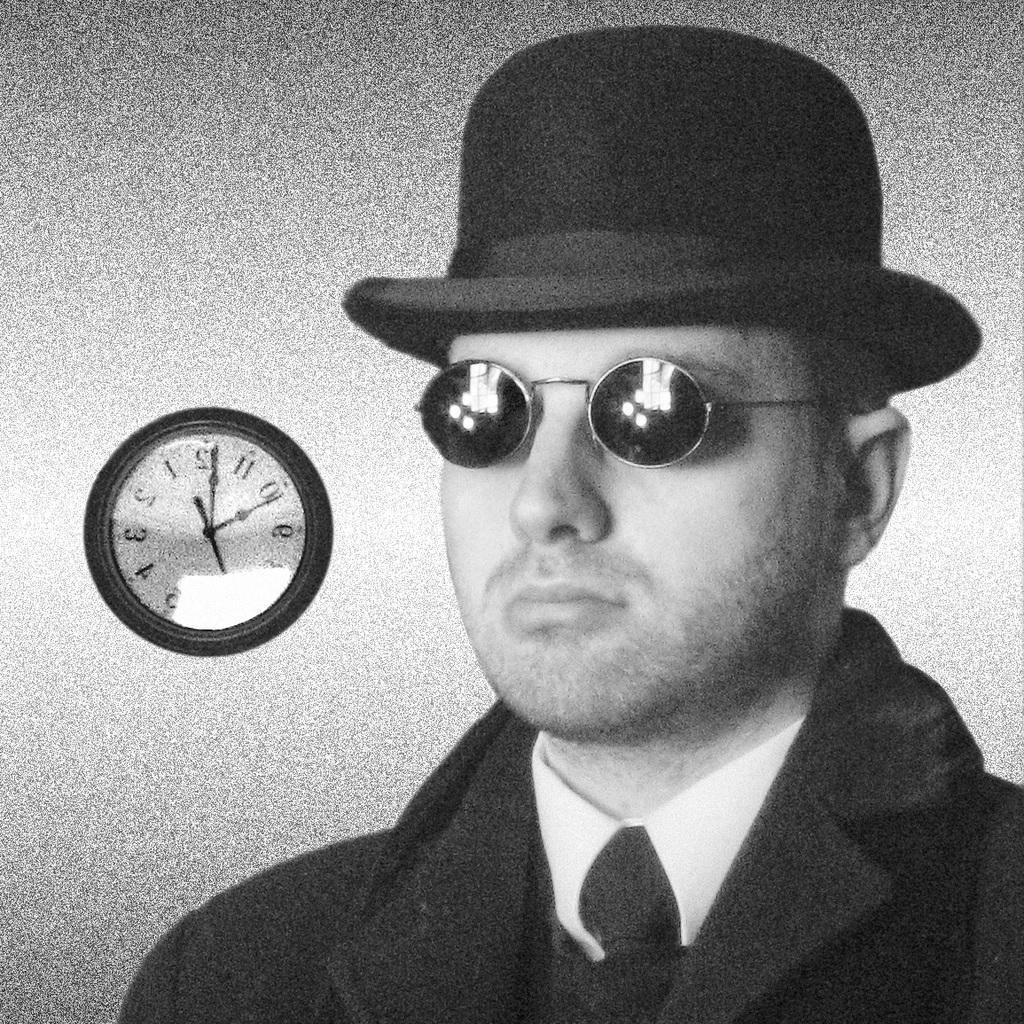What is the color scheme of the image? The image is black and white. Can you describe the person in the image? The person in the image is wearing glasses and a hat. What is present on the wall in the background of the image? There is a clock attached to the wall in the background of the image. How many boats are visible in the image? There are no boats present in the image. What type of cup is the person holding in the image? The person is not holding a cup in the image. 